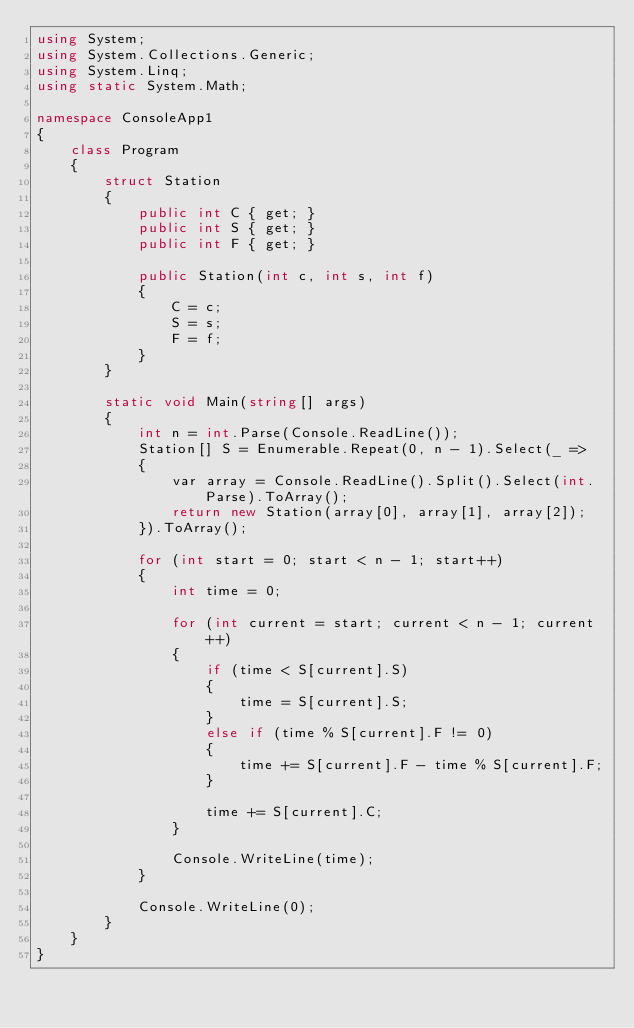<code> <loc_0><loc_0><loc_500><loc_500><_C#_>using System;
using System.Collections.Generic;
using System.Linq;
using static System.Math;

namespace ConsoleApp1
{
    class Program
    {
        struct Station
        {
            public int C { get; }
            public int S { get; }
            public int F { get; }

            public Station(int c, int s, int f)
            {
                C = c;
                S = s;
                F = f;
            }
        }

        static void Main(string[] args)
        {
            int n = int.Parse(Console.ReadLine());
            Station[] S = Enumerable.Repeat(0, n - 1).Select(_ =>
            {
                var array = Console.ReadLine().Split().Select(int.Parse).ToArray();
                return new Station(array[0], array[1], array[2]);
            }).ToArray();

            for (int start = 0; start < n - 1; start++)
            {
                int time = 0;

                for (int current = start; current < n - 1; current++)
                {
                    if (time < S[current].S)
                    {
                        time = S[current].S;
                    }
                    else if (time % S[current].F != 0)
                    {
                        time += S[current].F - time % S[current].F;
                    }

                    time += S[current].C;
                }

                Console.WriteLine(time);
            }

            Console.WriteLine(0);
        }
    }
}</code> 